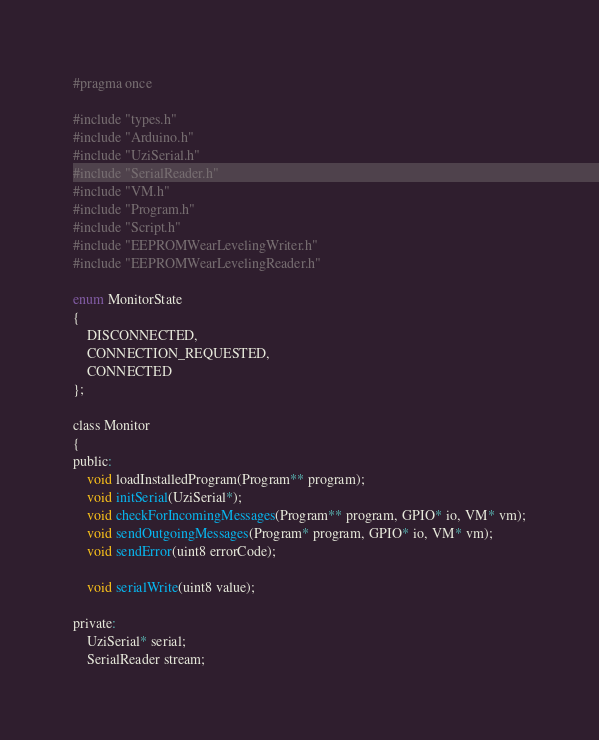<code> <loc_0><loc_0><loc_500><loc_500><_C_>#pragma once

#include "types.h"
#include "Arduino.h"
#include "UziSerial.h"
#include "SerialReader.h"
#include "VM.h"
#include "Program.h"
#include "Script.h"
#include "EEPROMWearLevelingWriter.h"
#include "EEPROMWearLevelingReader.h"

enum MonitorState
{
	DISCONNECTED,
	CONNECTION_REQUESTED,
	CONNECTED
};

class Monitor 
{
public:
	void loadInstalledProgram(Program** program);
	void initSerial(UziSerial*);
	void checkForIncomingMessages(Program** program, GPIO* io, VM* vm);
	void sendOutgoingMessages(Program* program, GPIO* io, VM* vm);
	void sendError(uint8 errorCode);

	void serialWrite(uint8 value);

private:
	UziSerial* serial;
	SerialReader stream;
</code> 